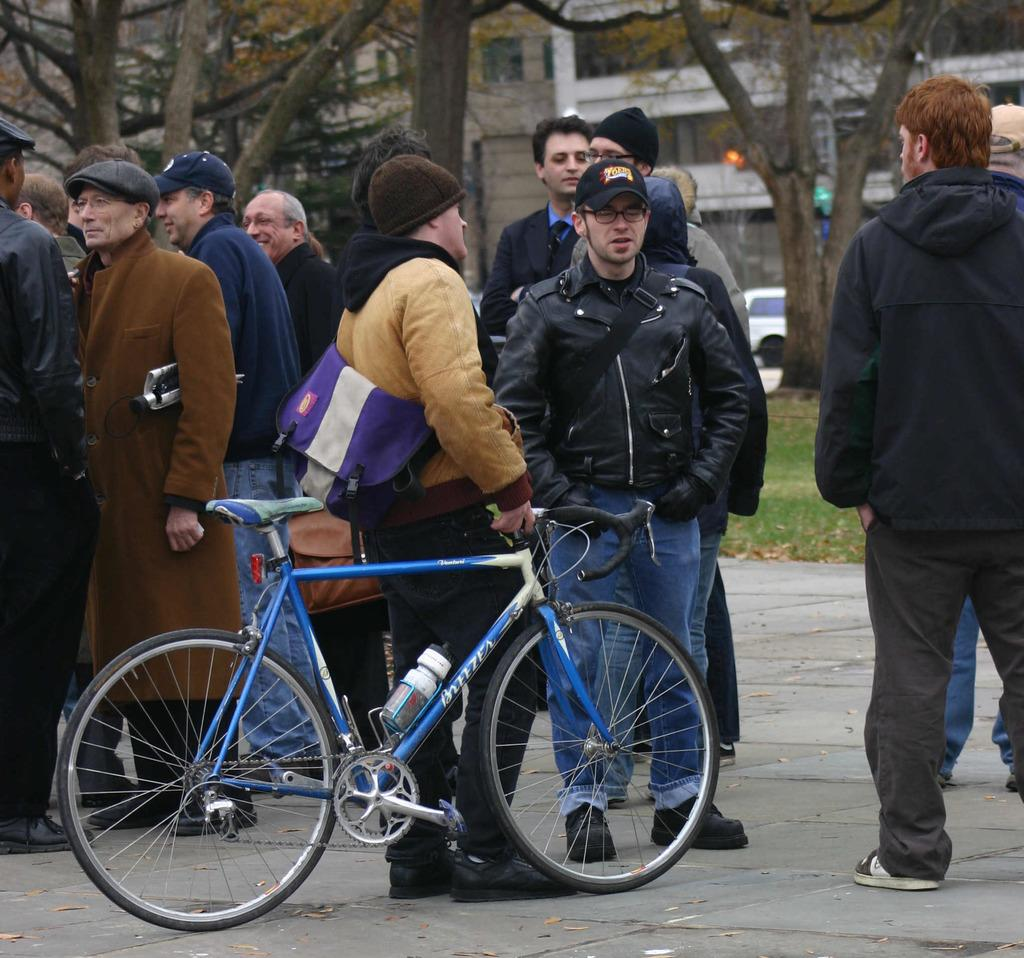What is the man in the image holding? The man is holding a cycle in the image. What can be seen on the ground in the image? There are people standing on a path in the image. What is visible in the background of the image? There are trees, a car, and buildings in the background of the image. What type of seed is being planted by the man in the image? There is no seed or planting activity depicted in the image; the man is holding a cycle. 